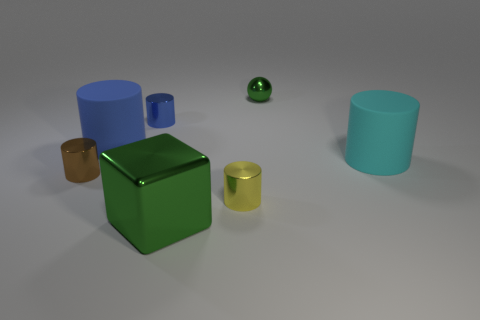What is the shape of the green thing that is behind the small brown cylinder?
Your response must be concise. Sphere. What is the size of the block that is the same material as the yellow object?
Provide a short and direct response. Large. How many other tiny things are the same shape as the tiny blue metal thing?
Your answer should be compact. 2. Does the tiny metallic thing behind the blue metallic cylinder have the same color as the block?
Offer a terse response. Yes. How many cylinders are left of the big object that is in front of the large matte thing that is right of the small green sphere?
Provide a short and direct response. 3. What number of green metal things are to the right of the big block and in front of the tiny blue shiny cylinder?
Make the answer very short. 0. What is the shape of the shiny object that is the same color as the large metallic cube?
Keep it short and to the point. Sphere. Are the big block and the sphere made of the same material?
Provide a short and direct response. Yes. What is the shape of the big rubber object behind the matte cylinder in front of the big rubber thing that is to the left of the big shiny thing?
Offer a very short reply. Cylinder. Is the number of green blocks on the left side of the tiny brown metal cylinder less than the number of tiny green objects that are behind the green ball?
Your answer should be very brief. No. 